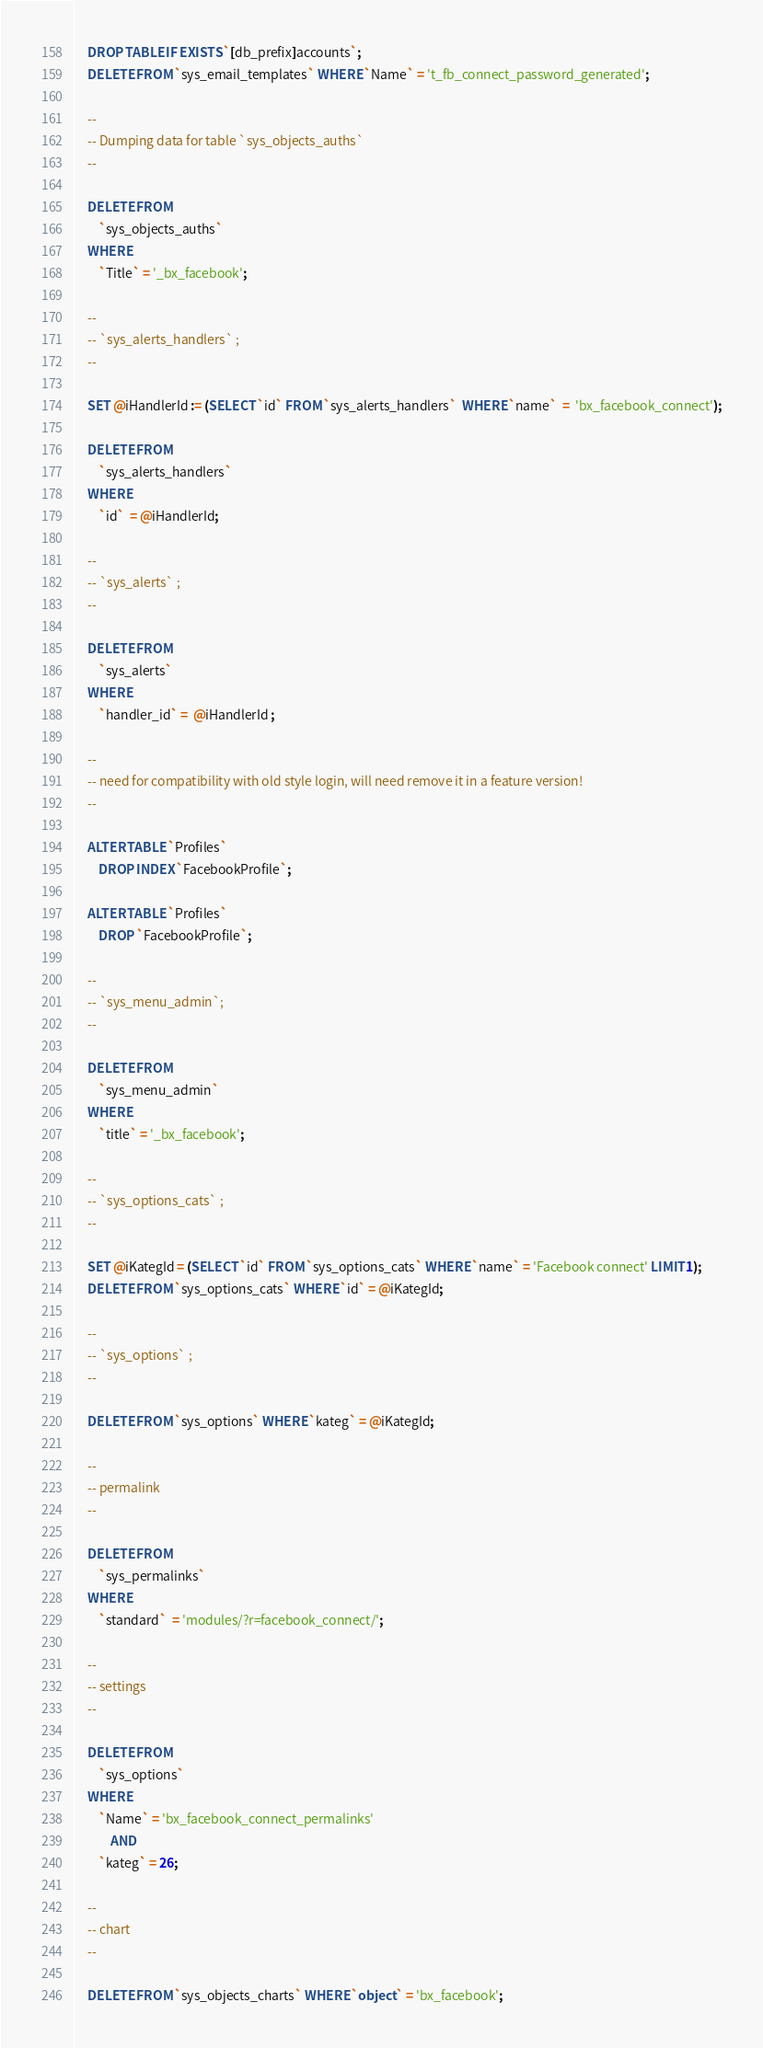Convert code to text. <code><loc_0><loc_0><loc_500><loc_500><_SQL_>
    DROP TABLE IF EXISTS `[db_prefix]accounts`;
	DELETE FROM `sys_email_templates` WHERE `Name` = 't_fb_connect_password_generated';

    --
    -- Dumping data for table `sys_objects_auths`
    --

    DELETE FROM 
        `sys_objects_auths` 
    WHERE    
        `Title` = '_bx_facebook';
 
    --
    -- `sys_alerts_handlers` ;
    --

    SET @iHandlerId := (SELECT `id` FROM `sys_alerts_handlers`  WHERE `name`  =  'bx_facebook_connect');

    DELETE FROM
        `sys_alerts_handlers`
    WHERE
        `id`  = @iHandlerId;

    --
    -- `sys_alerts` ;
    --

    DELETE FROM 
        `sys_alerts`
    WHERE
        `handler_id` =  @iHandlerId ;

    --
    -- need for compatibility with old style login, will need remove it in a feature version!
    --

	ALTER TABLE `Profiles` 
		DROP INDEX `FacebookProfile`;

    ALTER TABLE `Profiles`
        DROP `FacebookProfile`;

    -- 
    -- `sys_menu_admin`;
    --

    DELETE FROM 
        `sys_menu_admin` 
    WHERE
        `title` = '_bx_facebook';

    --
    -- `sys_options_cats` ;
    --

    SET @iKategId = (SELECT `id` FROM `sys_options_cats` WHERE `name` = 'Facebook connect' LIMIT 1);
    DELETE FROM `sys_options_cats` WHERE `id` = @iKategId;

    --
    -- `sys_options` ;
    --

    DELETE FROM `sys_options` WHERE `kateg` = @iKategId;

    --
    -- permalink
    --

    DELETE FROM 
        `sys_permalinks` 
    WHERE
        `standard`  = 'modules/?r=facebook_connect/';

    --
    -- settings
    --

    DELETE FROM 
        `sys_options` 
    WHERE
        `Name` = 'bx_facebook_connect_permalinks'
            AND
        `kateg` = 26;

    --
    -- chart
    --

    DELETE FROM `sys_objects_charts` WHERE `object` = 'bx_facebook';


</code> 